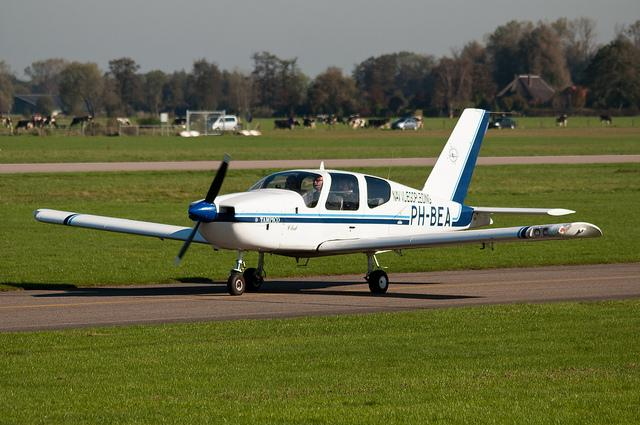What area is behind Plane runway? Please explain your reasoning. cow field. You can see black and white cows in the background. 